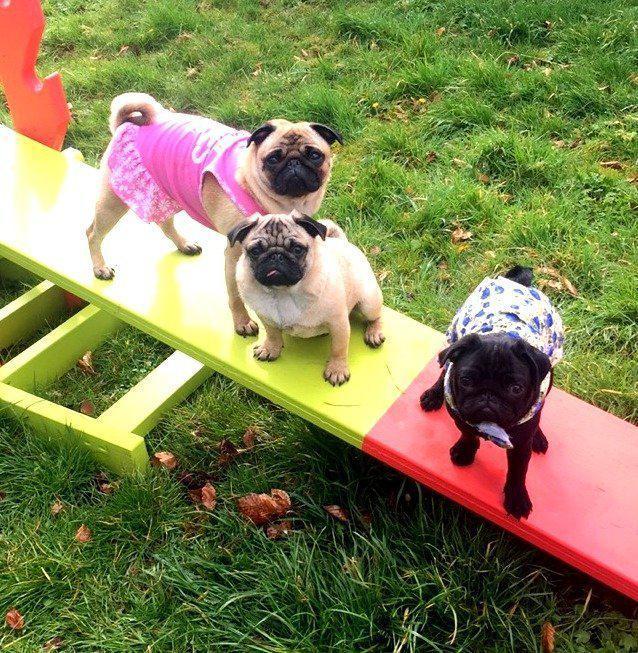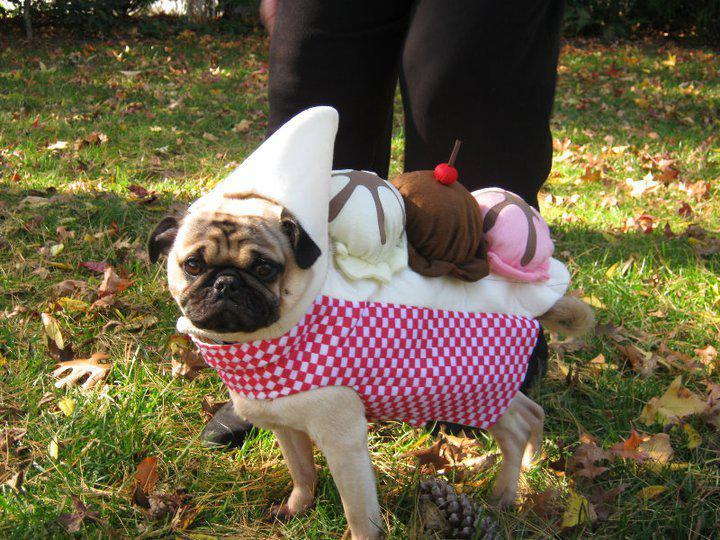The first image is the image on the left, the second image is the image on the right. For the images shown, is this caption "One of the four pugs is wearing a hat." true? Answer yes or no. Yes. The first image is the image on the left, the second image is the image on the right. Analyze the images presented: Is the assertion "The right image includes at least one standing beige pug on a leash, and the left image features three forward-facing beige pugs wearing some type of attire." valid? Answer yes or no. No. 